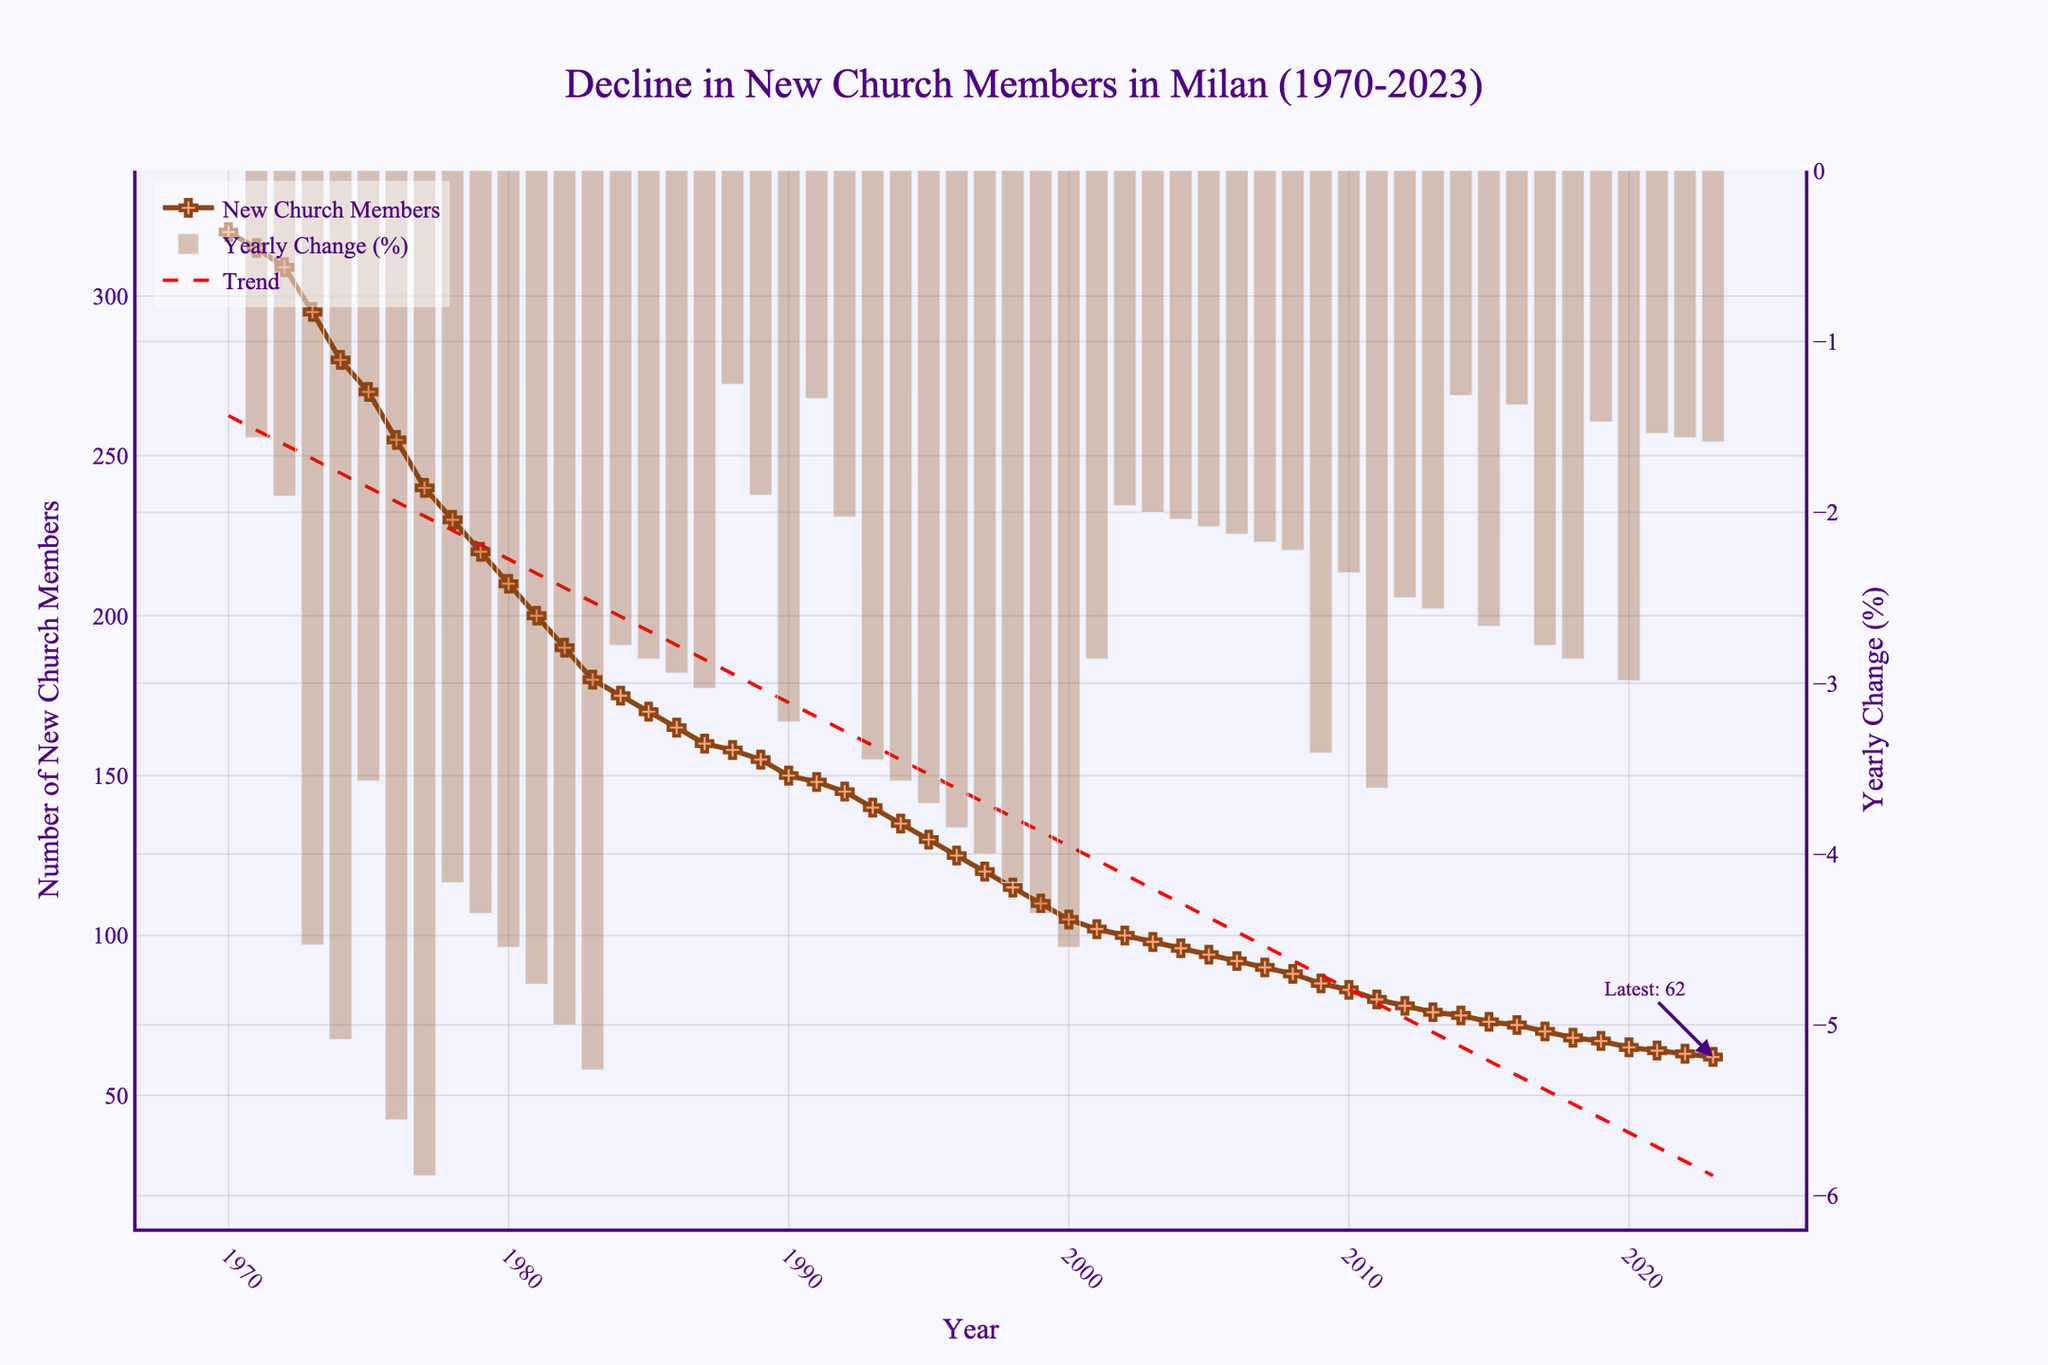What's the title of the plot? The title is displayed prominently at the top of the plot. It reads "Decline in New Church Members in Milan (1970-2023)"
Answer: Decline in New Church Members in Milan (1970-2023) How many new church members were there in 1970? By looking at the beginning of the plot along the Y-axis and the line marker for the year 1970, the number of new church members can be observed.
Answer: 320 When did the number of new church members fall below 100 for the first time? By following the downward trend line along the Y-axis and identifying the first data point that falls below 100, you can determine the year.
Answer: 2002 What was the yearly change percentage in the number of new church members in 1990? Observe the secondary Y-axis that shows the yearly change (%) and find the bar for the year 1990 to identify the value.
Answer: Around -3.23% Compare the number of new church members in 1980 and 2023. Locate both years along the X-axis, and compare the corresponding Y-axis values. In 1980, the number is 210, and in 2023, it is 62.
Answer: 1980: 210, 2023: 62 What was the percentage change from 1970 to 1985? Calculate the percentage change using the formula: ((Value in 1985 - Value in 1970) / Value in 1970) * 100. This requires noting the values in 1970 (320) and 1985 (170).
Answer: -46.88% Identify the year with the smallest decrease in the number of new church members. Observe the bars representing yearly changes across the figure and identify the shortest bar. This indicates the year with the smallest decrease.
Answer: 1988 How does the trend line compare to the actual number of new church members over the years? The trend line can be observed in red dashed format, comparing it with the actual data points shows a continuous decline. The trend line generally follows the downward trend of the actual data.
Answer: Continuous decline, similar to the actual data What is the general trend observed in the number of new church members from 1970 to 2023? The plot shows a steady and continuous decline in the number of new church members from 1970 to 2023.
Answer: Steady decline 